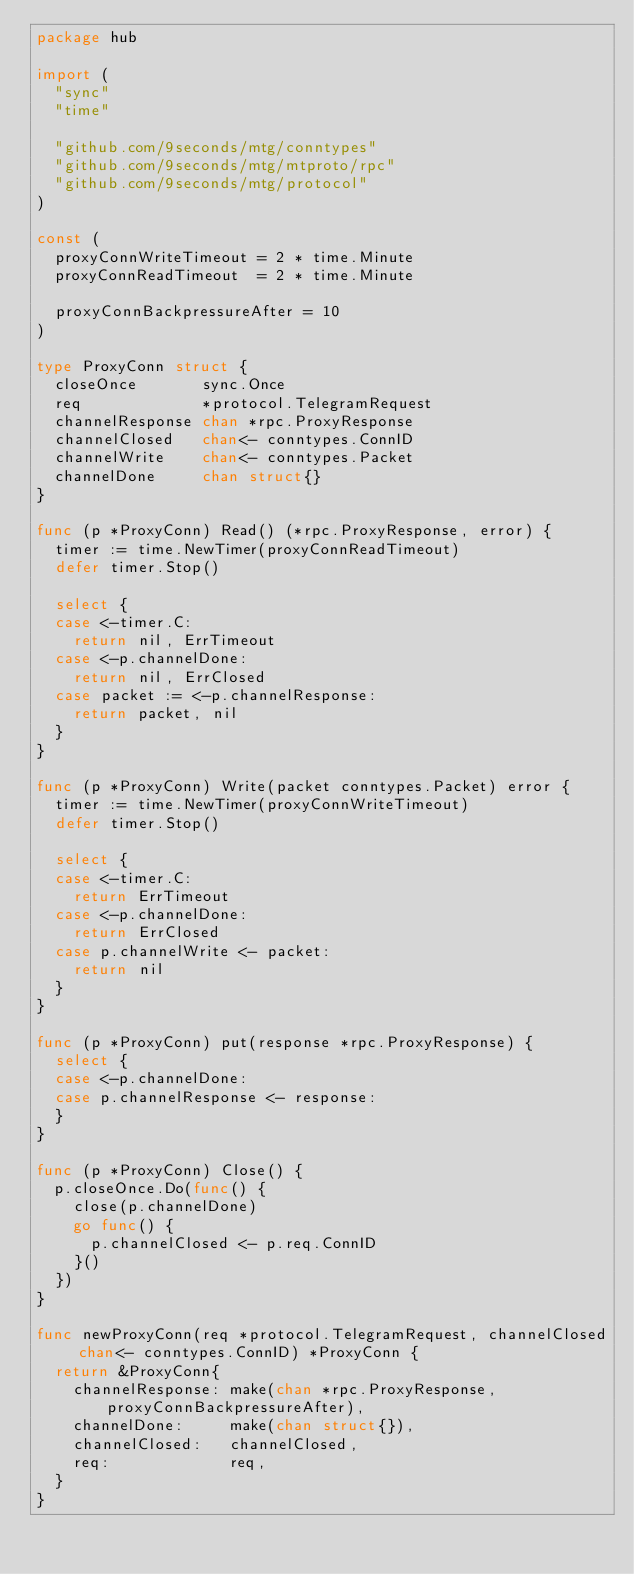<code> <loc_0><loc_0><loc_500><loc_500><_Go_>package hub

import (
	"sync"
	"time"

	"github.com/9seconds/mtg/conntypes"
	"github.com/9seconds/mtg/mtproto/rpc"
	"github.com/9seconds/mtg/protocol"
)

const (
	proxyConnWriteTimeout = 2 * time.Minute
	proxyConnReadTimeout  = 2 * time.Minute

	proxyConnBackpressureAfter = 10
)

type ProxyConn struct {
	closeOnce       sync.Once
	req             *protocol.TelegramRequest
	channelResponse chan *rpc.ProxyResponse
	channelClosed   chan<- conntypes.ConnID
	channelWrite    chan<- conntypes.Packet
	channelDone     chan struct{}
}

func (p *ProxyConn) Read() (*rpc.ProxyResponse, error) {
	timer := time.NewTimer(proxyConnReadTimeout)
	defer timer.Stop()

	select {
	case <-timer.C:
		return nil, ErrTimeout
	case <-p.channelDone:
		return nil, ErrClosed
	case packet := <-p.channelResponse:
		return packet, nil
	}
}

func (p *ProxyConn) Write(packet conntypes.Packet) error {
	timer := time.NewTimer(proxyConnWriteTimeout)
	defer timer.Stop()

	select {
	case <-timer.C:
		return ErrTimeout
	case <-p.channelDone:
		return ErrClosed
	case p.channelWrite <- packet:
		return nil
	}
}

func (p *ProxyConn) put(response *rpc.ProxyResponse) {
	select {
	case <-p.channelDone:
	case p.channelResponse <- response:
	}
}

func (p *ProxyConn) Close() {
	p.closeOnce.Do(func() {
		close(p.channelDone)
		go func() {
			p.channelClosed <- p.req.ConnID
		}()
	})
}

func newProxyConn(req *protocol.TelegramRequest, channelClosed chan<- conntypes.ConnID) *ProxyConn {
	return &ProxyConn{
		channelResponse: make(chan *rpc.ProxyResponse, proxyConnBackpressureAfter),
		channelDone:     make(chan struct{}),
		channelClosed:   channelClosed,
		req:             req,
	}
}
</code> 